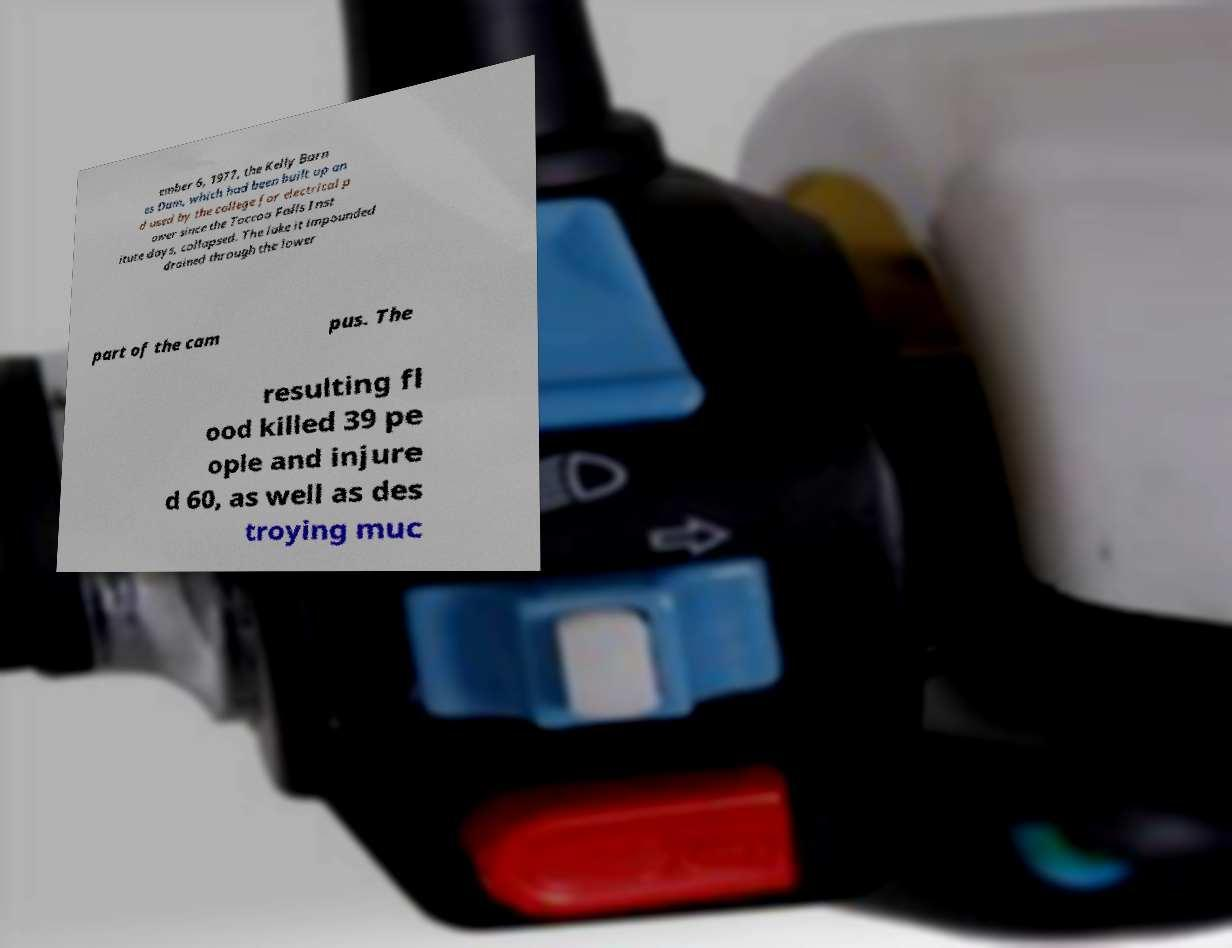There's text embedded in this image that I need extracted. Can you transcribe it verbatim? ember 6, 1977, the Kelly Barn es Dam, which had been built up an d used by the college for electrical p ower since the Toccoa Falls Inst itute days, collapsed. The lake it impounded drained through the lower part of the cam pus. The resulting fl ood killed 39 pe ople and injure d 60, as well as des troying muc 